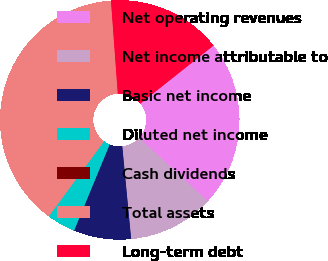Convert chart. <chart><loc_0><loc_0><loc_500><loc_500><pie_chart><fcel>Net operating revenues<fcel>Net income attributable to<fcel>Basic net income<fcel>Diluted net income<fcel>Cash dividends<fcel>Total assets<fcel>Long-term debt<nl><fcel>22.54%<fcel>11.62%<fcel>7.75%<fcel>3.87%<fcel>0.0%<fcel>38.73%<fcel>15.49%<nl></chart> 